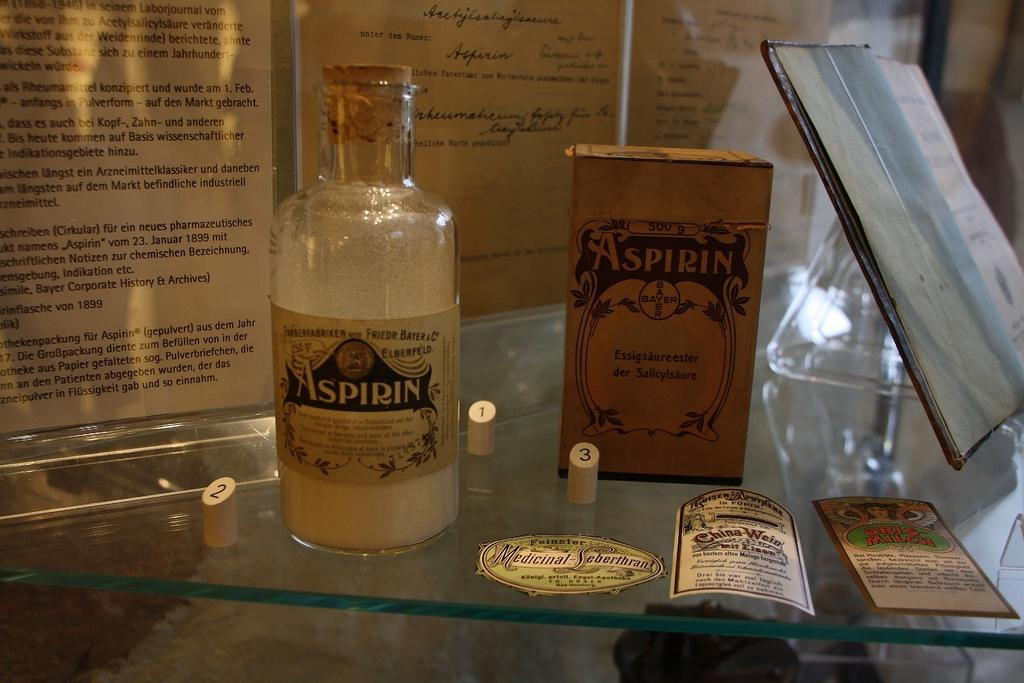<image>
Summarize the visual content of the image. Vintage containers of Bayer Aspirin are on a glass shelf. 